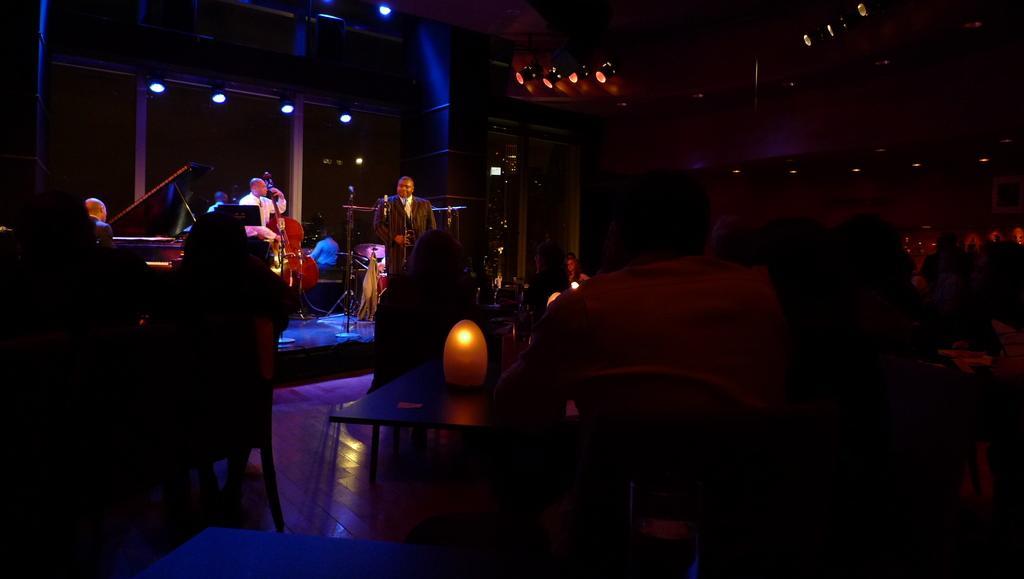How would you summarize this image in a sentence or two? In the picture we can see group of people playing musical instruments and we can see some tables, chairs and top of the picture there are some lights. 